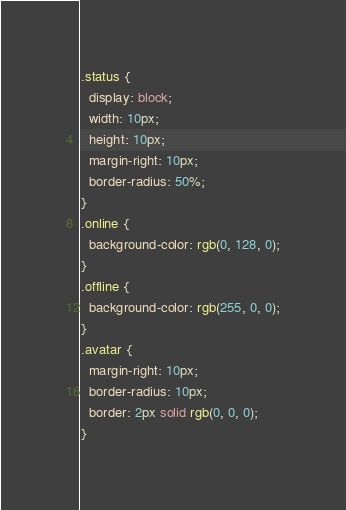<code> <loc_0><loc_0><loc_500><loc_500><_CSS_>.status {
  display: block;
  width: 10px;
  height: 10px;
  margin-right: 10px;
  border-radius: 50%;
}
.online {
  background-color: rgb(0, 128, 0);
}
.offline {
  background-color: rgb(255, 0, 0);
}
.avatar {
  margin-right: 10px;
  border-radius: 10px;
  border: 2px solid rgb(0, 0, 0);
}
</code> 